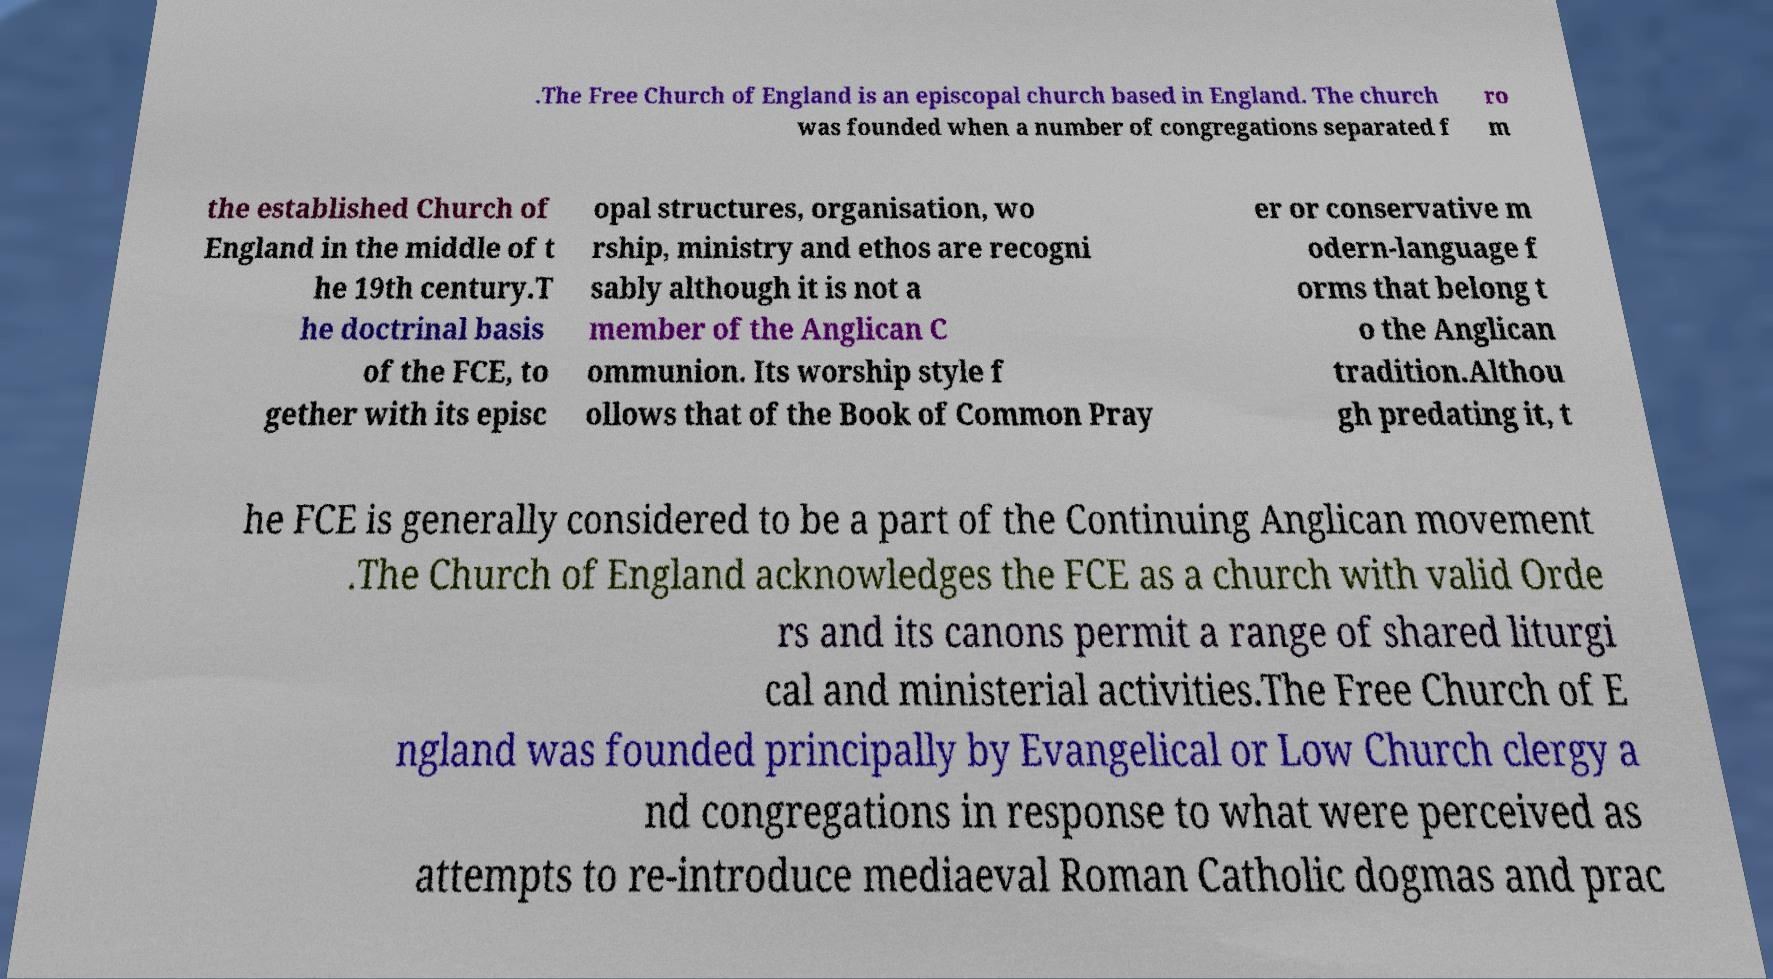What messages or text are displayed in this image? I need them in a readable, typed format. .The Free Church of England is an episcopal church based in England. The church was founded when a number of congregations separated f ro m the established Church of England in the middle of t he 19th century.T he doctrinal basis of the FCE, to gether with its episc opal structures, organisation, wo rship, ministry and ethos are recogni sably although it is not a member of the Anglican C ommunion. Its worship style f ollows that of the Book of Common Pray er or conservative m odern-language f orms that belong t o the Anglican tradition.Althou gh predating it, t he FCE is generally considered to be a part of the Continuing Anglican movement .The Church of England acknowledges the FCE as a church with valid Orde rs and its canons permit a range of shared liturgi cal and ministerial activities.The Free Church of E ngland was founded principally by Evangelical or Low Church clergy a nd congregations in response to what were perceived as attempts to re-introduce mediaeval Roman Catholic dogmas and prac 